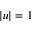Convert formula to latex. <formula><loc_0><loc_0><loc_500><loc_500>| u | = 1</formula> 